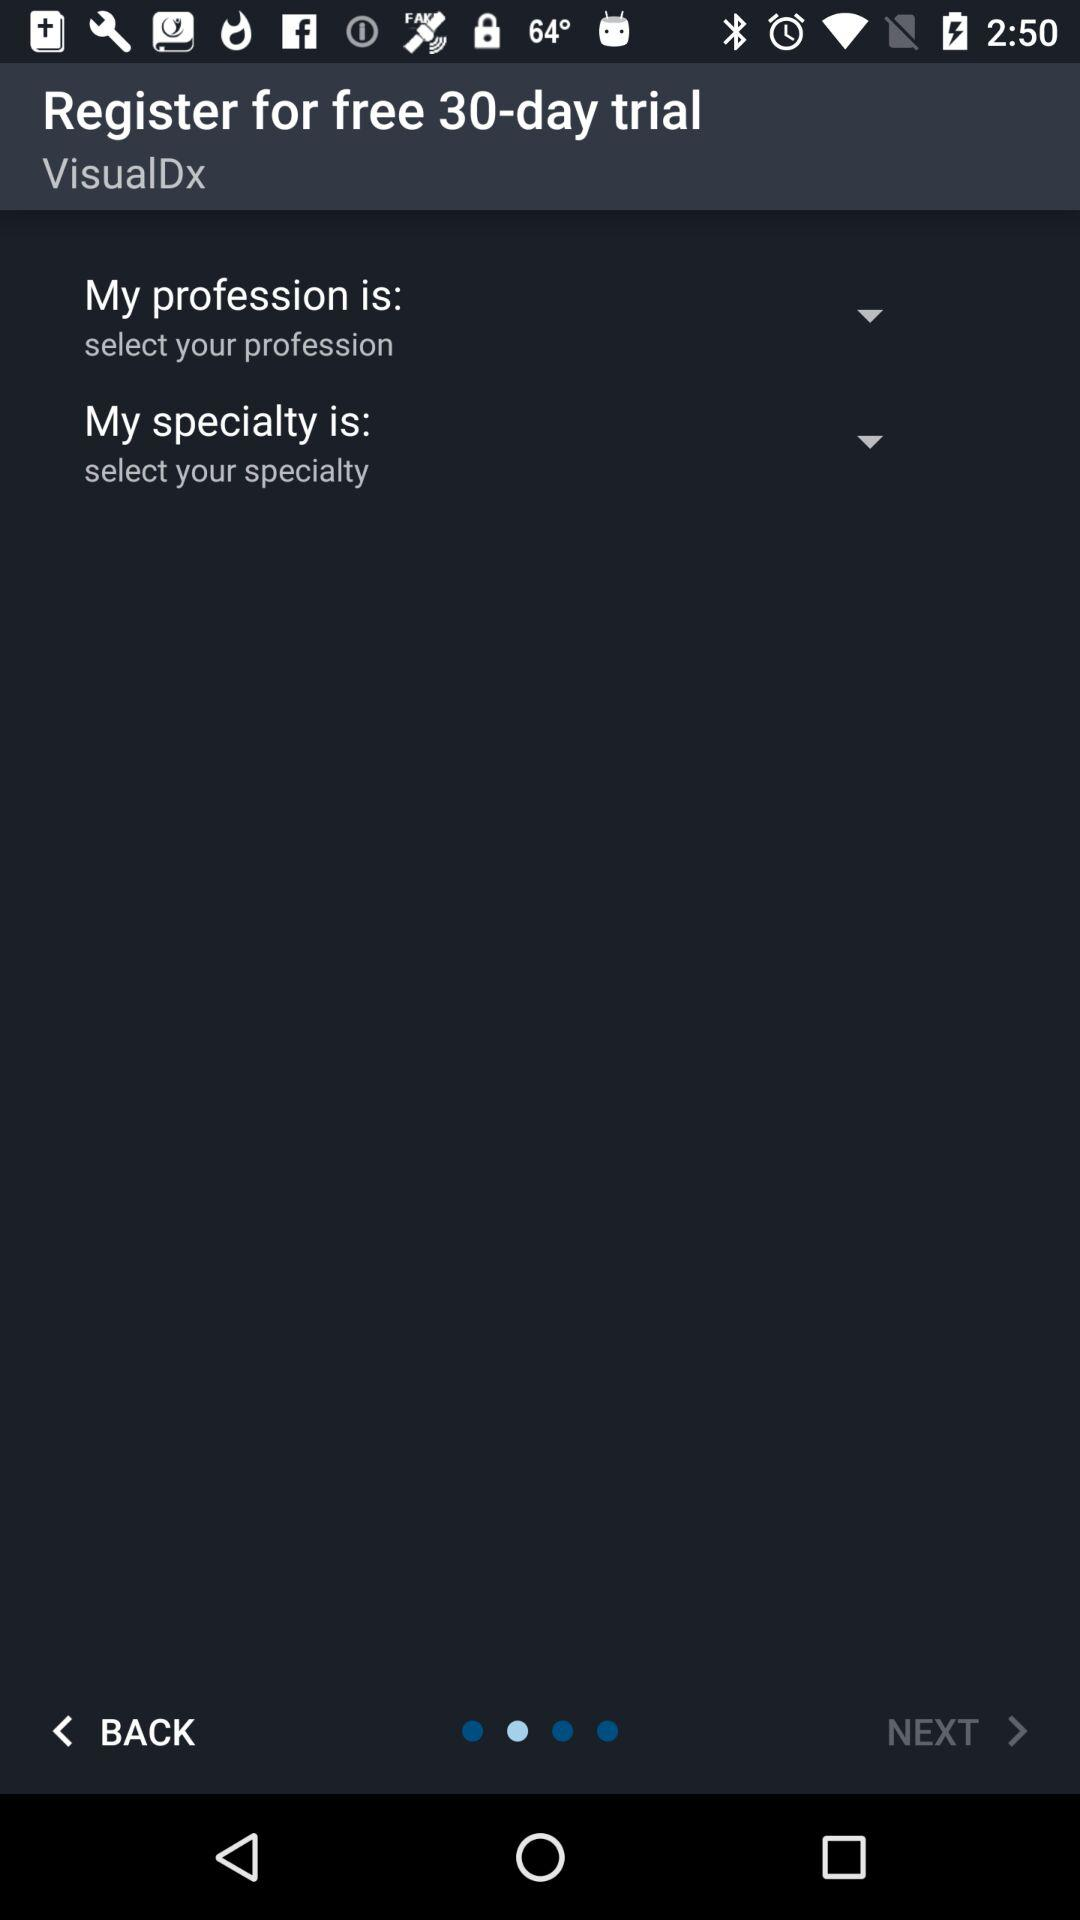For how many days will the free trial last? The free trial will last for 30 days. 